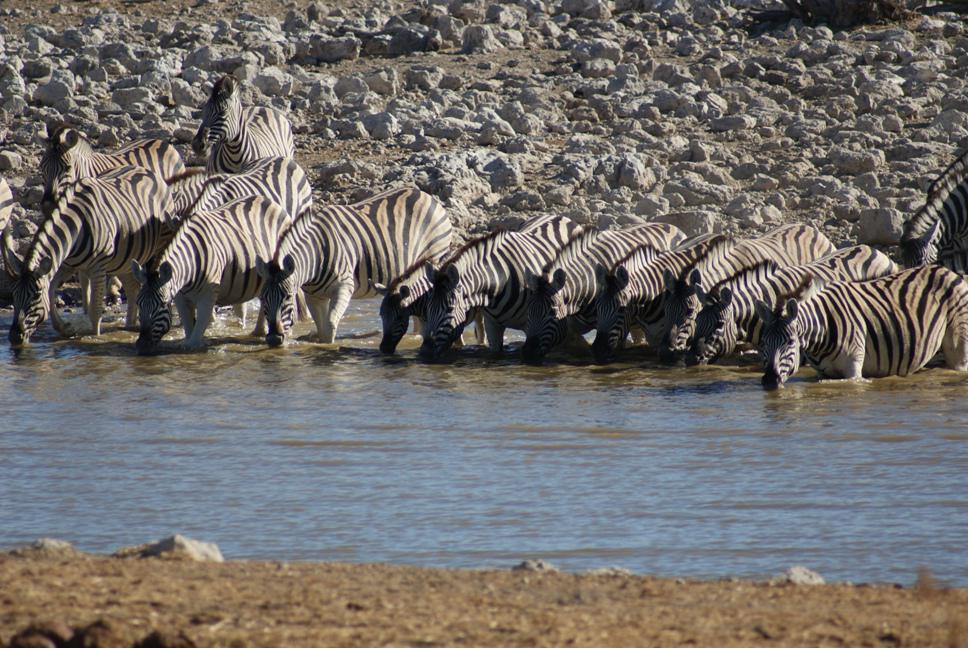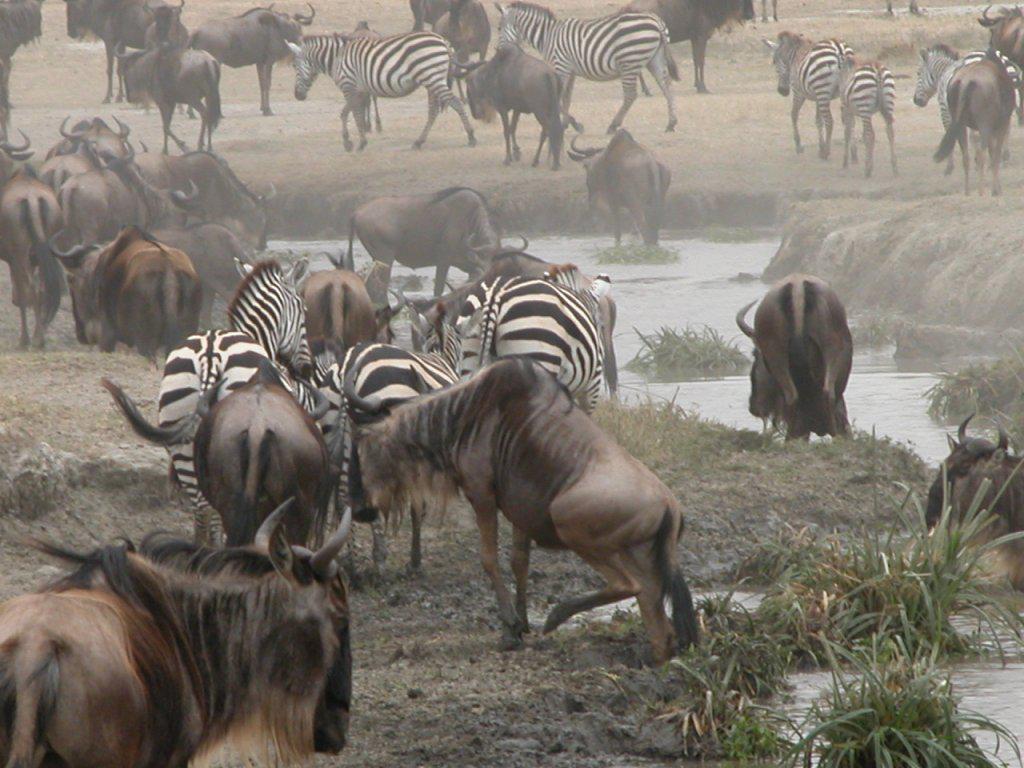The first image is the image on the left, the second image is the image on the right. Examine the images to the left and right. Is the description "Multiple zebras and gnus, including multiple rear-facing animals, are at a watering hole in one image." accurate? Answer yes or no. Yes. The first image is the image on the left, the second image is the image on the right. Evaluate the accuracy of this statement regarding the images: "In one image, only zebras and no other species can be seen.". Is it true? Answer yes or no. Yes. 